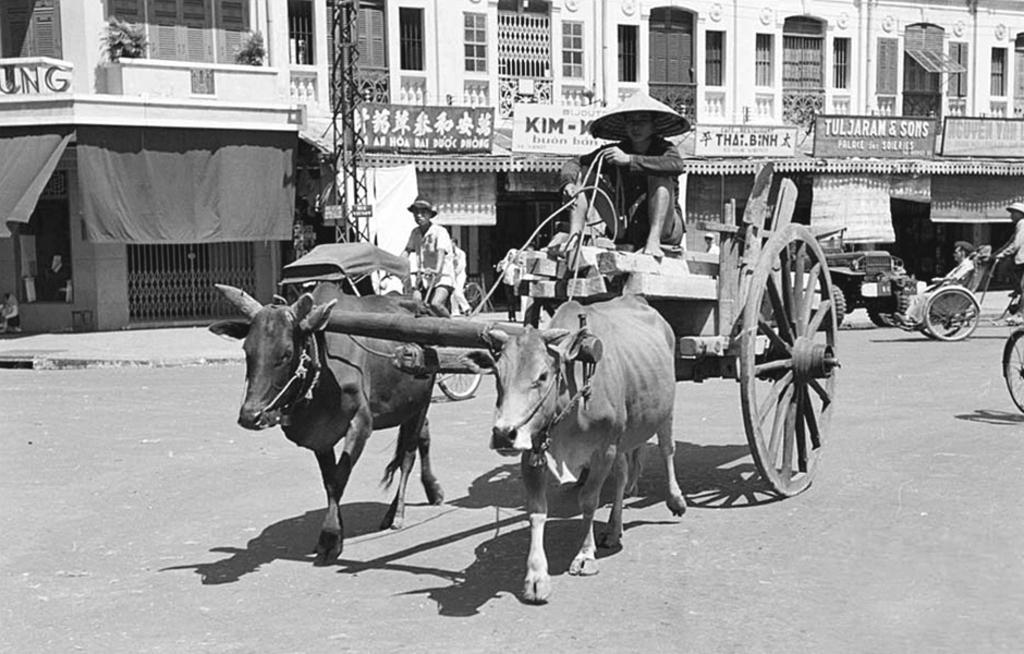Describe this image in one or two sentences. In the picture we can see some group of persons riding vehicles on road, in the foreground of the picture there is a person riding bullock cart and in the background of the picture there are some buildings to which boards are attached. 